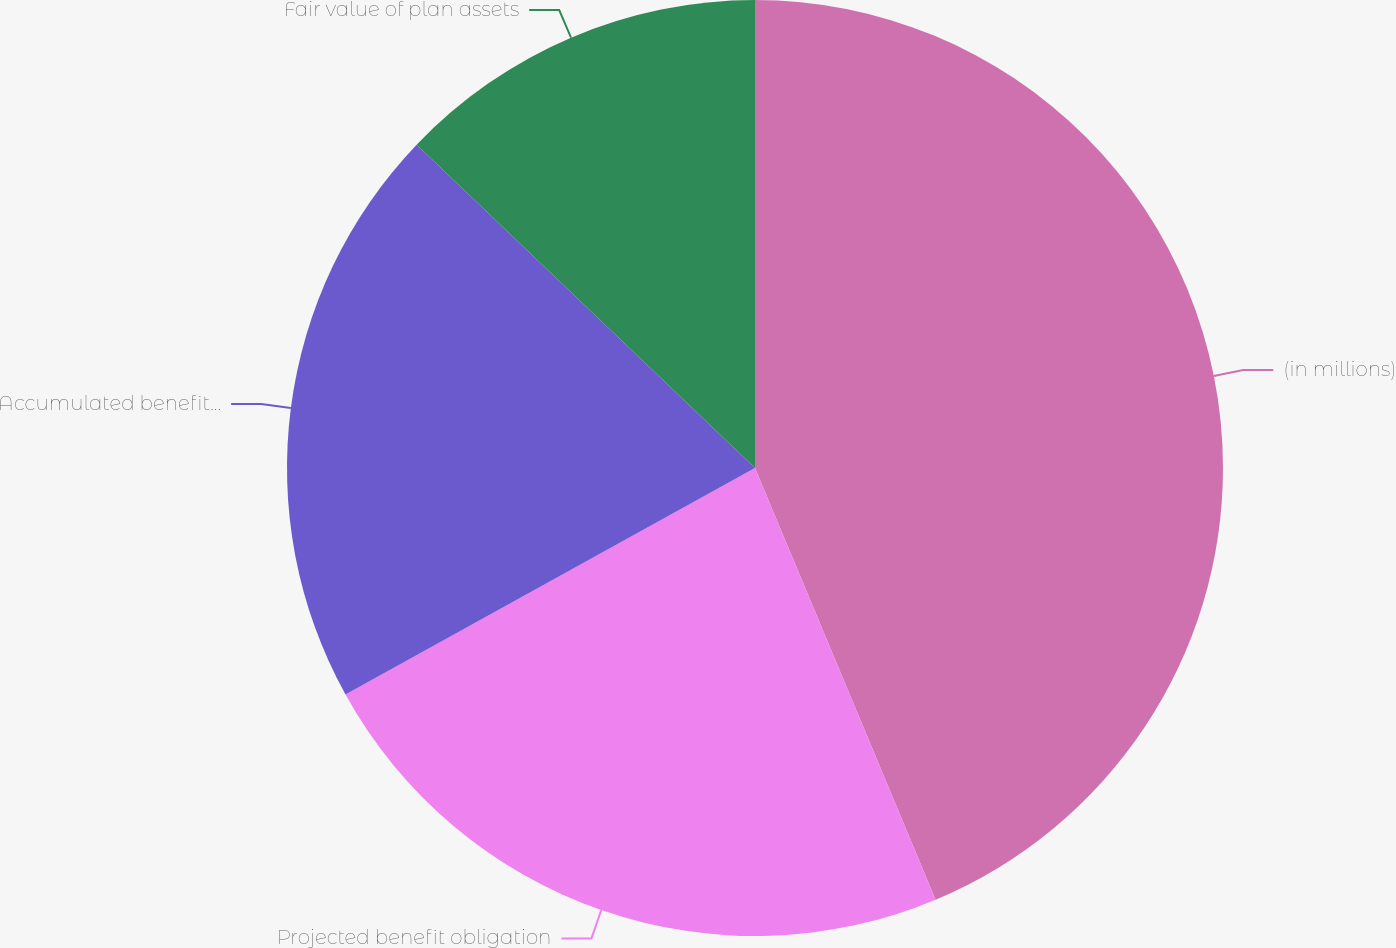Convert chart. <chart><loc_0><loc_0><loc_500><loc_500><pie_chart><fcel>(in millions)<fcel>Projected benefit obligation<fcel>Accumulated benefit obligation<fcel>Fair value of plan assets<nl><fcel>43.69%<fcel>23.26%<fcel>20.18%<fcel>12.86%<nl></chart> 